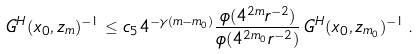Convert formula to latex. <formula><loc_0><loc_0><loc_500><loc_500>G ^ { H } ( x _ { 0 } , z _ { m } ) ^ { - 1 } \leq c _ { 5 } 4 ^ { - \gamma ( m - m _ { 0 } ) } \frac { \phi ( 4 ^ { 2 m } r ^ { - 2 } ) } { \phi ( 4 ^ { 2 m _ { 0 } } r ^ { - 2 } ) } \, G ^ { H } ( x _ { 0 } , z _ { m _ { 0 } } ) ^ { - 1 } \, .</formula> 